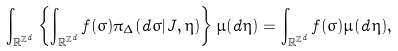<formula> <loc_0><loc_0><loc_500><loc_500>\int _ { \mathbb { R } ^ { \mathbb { Z } ^ { d } } } \left \{ \int _ { \mathbb { R } ^ { \mathbb { Z } ^ { d } } } f ( \sigma ) \pi _ { \Delta } ( d \sigma | J , \eta ) \right \} \mu ( d \eta ) = \int _ { \mathbb { R } ^ { \mathbb { Z } ^ { d } } } f ( \sigma ) \mu ( d \eta ) ,</formula> 